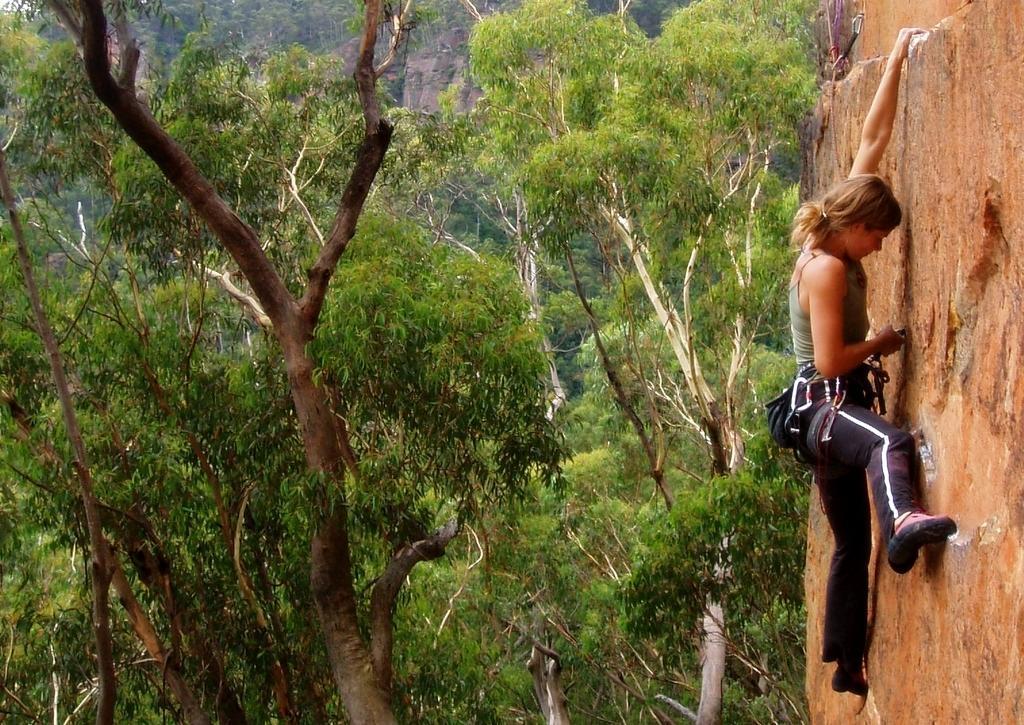Could you give a brief overview of what you see in this image? In this picture I can see a woman climbing the rock and I can see trees. 